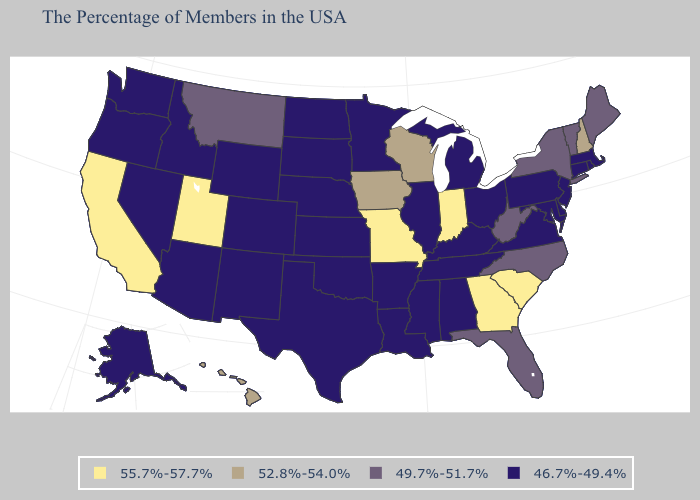What is the highest value in the South ?
Be succinct. 55.7%-57.7%. Does the map have missing data?
Keep it brief. No. Does Massachusetts have the lowest value in the Northeast?
Answer briefly. Yes. Which states have the highest value in the USA?
Concise answer only. South Carolina, Georgia, Indiana, Missouri, Utah, California. What is the lowest value in states that border New Hampshire?
Answer briefly. 46.7%-49.4%. What is the value of Michigan?
Quick response, please. 46.7%-49.4%. What is the value of South Dakota?
Keep it brief. 46.7%-49.4%. Among the states that border Tennessee , does Georgia have the lowest value?
Be succinct. No. Does Alabama have the highest value in the USA?
Short answer required. No. Which states have the lowest value in the USA?
Short answer required. Massachusetts, Rhode Island, Connecticut, New Jersey, Delaware, Maryland, Pennsylvania, Virginia, Ohio, Michigan, Kentucky, Alabama, Tennessee, Illinois, Mississippi, Louisiana, Arkansas, Minnesota, Kansas, Nebraska, Oklahoma, Texas, South Dakota, North Dakota, Wyoming, Colorado, New Mexico, Arizona, Idaho, Nevada, Washington, Oregon, Alaska. Which states have the lowest value in the USA?
Short answer required. Massachusetts, Rhode Island, Connecticut, New Jersey, Delaware, Maryland, Pennsylvania, Virginia, Ohio, Michigan, Kentucky, Alabama, Tennessee, Illinois, Mississippi, Louisiana, Arkansas, Minnesota, Kansas, Nebraska, Oklahoma, Texas, South Dakota, North Dakota, Wyoming, Colorado, New Mexico, Arizona, Idaho, Nevada, Washington, Oregon, Alaska. What is the value of New Hampshire?
Concise answer only. 52.8%-54.0%. Does North Dakota have the lowest value in the MidWest?
Be succinct. Yes. Name the states that have a value in the range 49.7%-51.7%?
Quick response, please. Maine, Vermont, New York, North Carolina, West Virginia, Florida, Montana. 